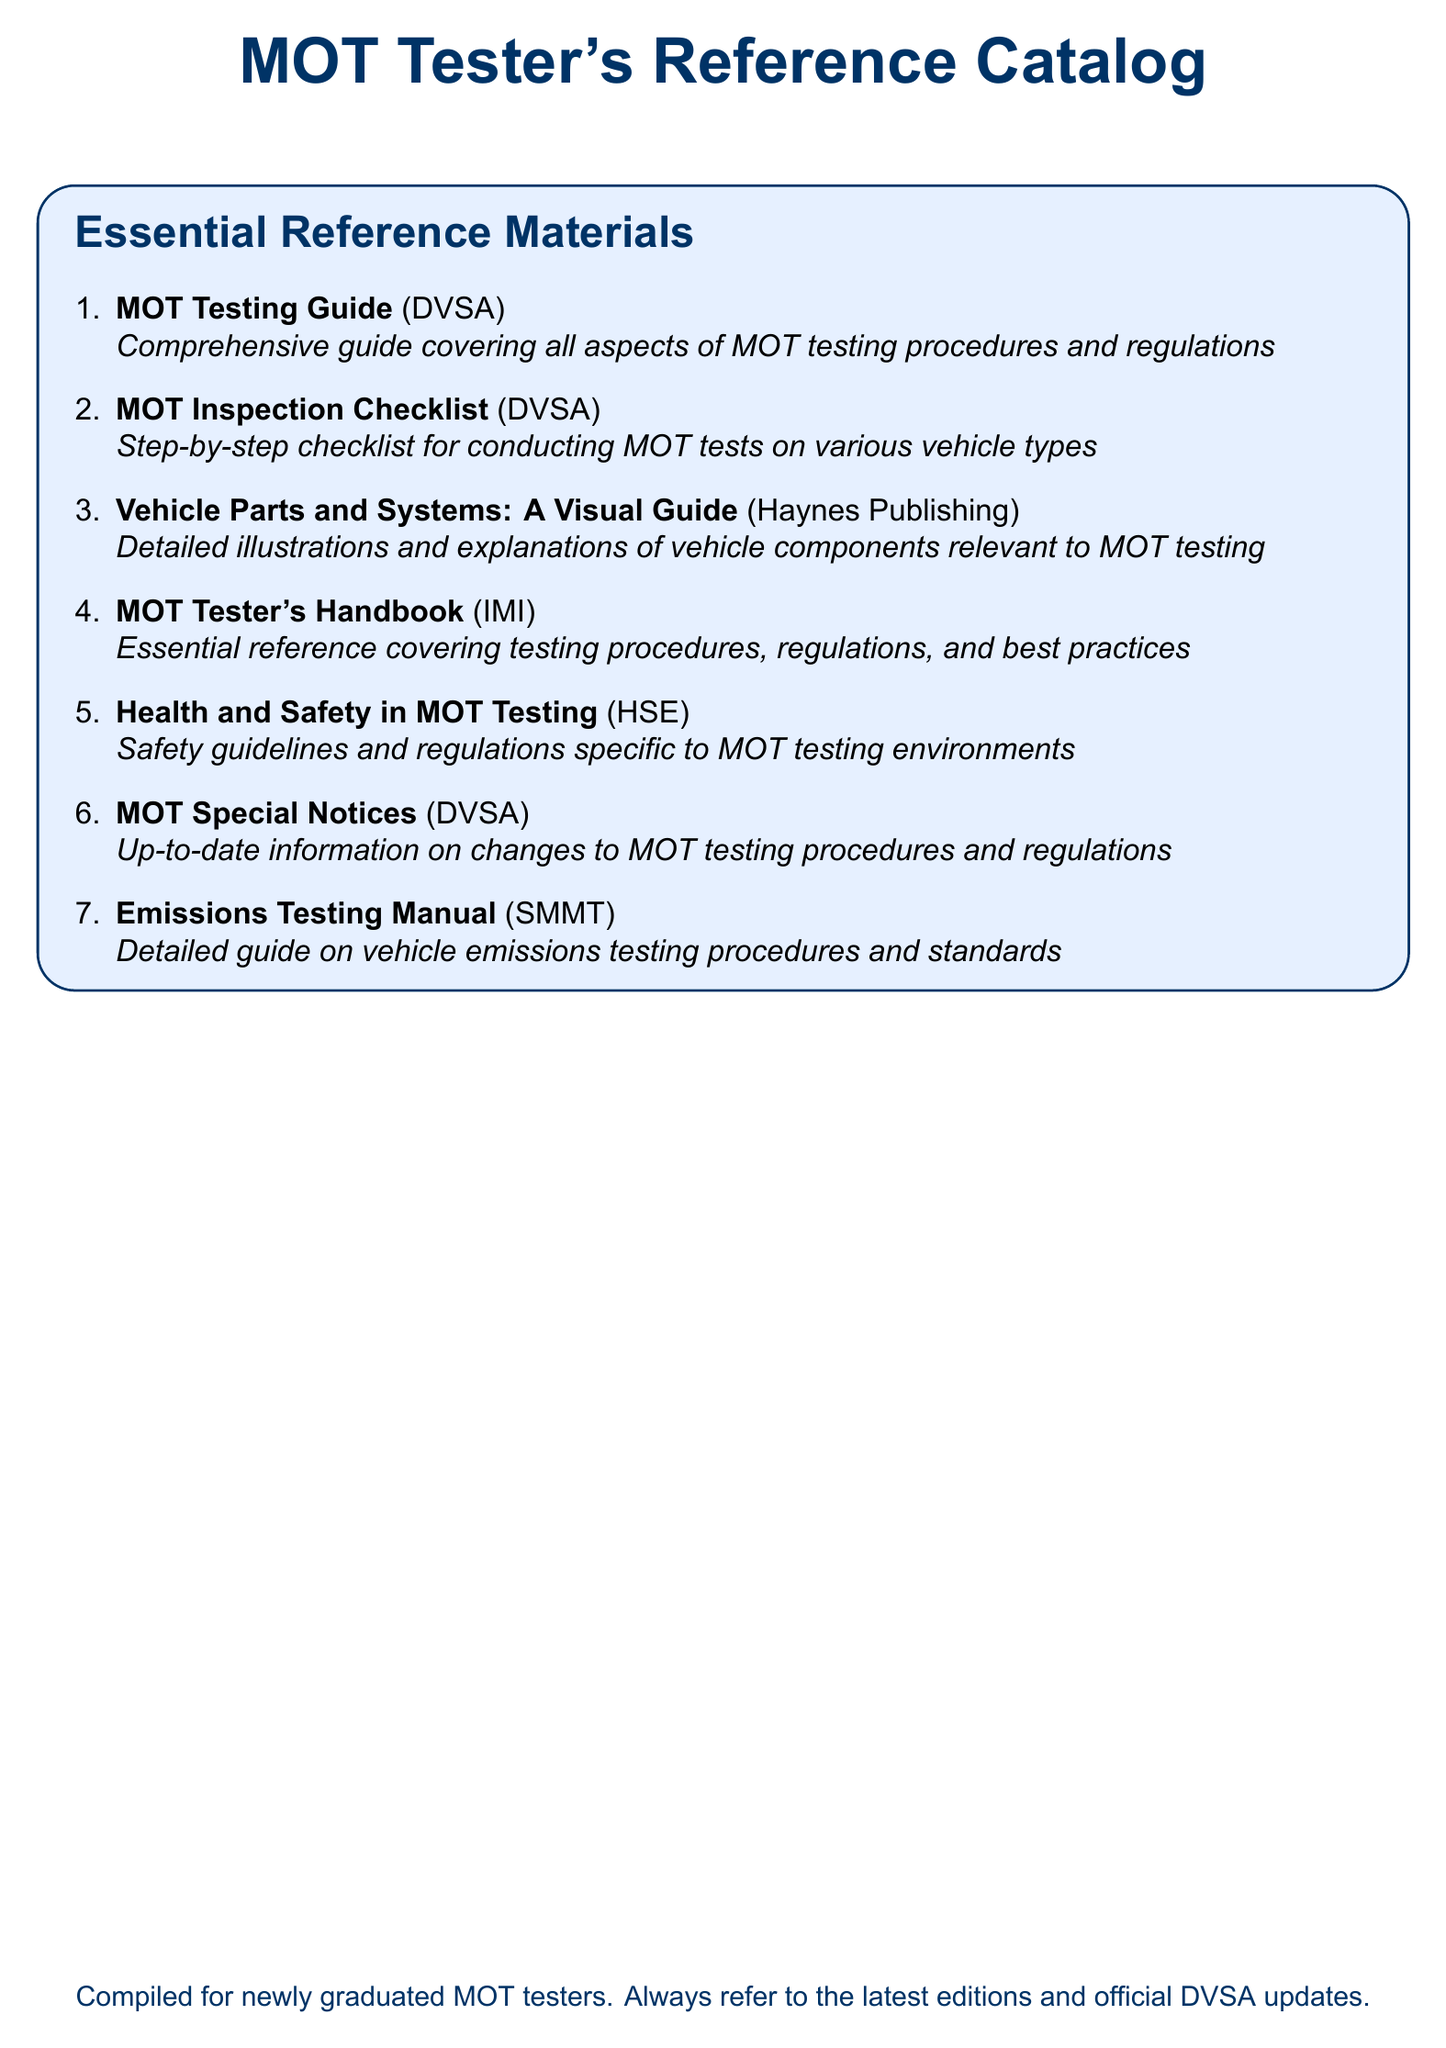What is the title of the catalog? The title of the catalog is the main heading and indicates the type of reference it serves, which is “MOT Tester's Reference Catalog.”
Answer: MOT Tester's Reference Catalog Who published the MOT Testing Guide? The document lists the publisher of the MOT Testing Guide, which is the DVSA.
Answer: DVSA What type of guide is the Emissions Testing Manual? The Emissions Testing Manual is categorized as a “Detailed guide.”
Answer: Detailed guide How many essential reference materials are listed? The document presents a list and counts the items under "Essential Reference Materials." There are seven items.
Answer: 7 What is the purpose of the MOT Inspection Checklist? The MOT Inspection Checklist serves as a step-by-step guide for conducting MOT tests, pointing to its specific function.
Answer: Step-by-step checklist What organization provides the up-to-date information on MOT testing procedures? The source of up-to-date information, as mentioned in the document, is the DVSA.
Answer: DVSA Which publication focuses on Health and Safety in MOT Testing? The document specifies that Health and Safety in MOT Testing is provided by HSE.
Answer: HSE What is the emphasis of the Vehicle Parts and Systems guide? The emphasis is on providing detailed illustrations and explanations, as indicated in the description.
Answer: Detailed illustrations and explanations 